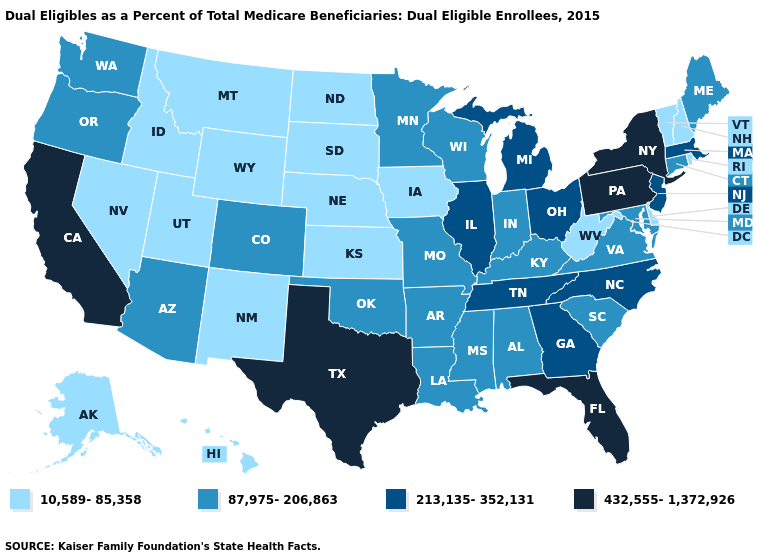Among the states that border Virginia , does West Virginia have the lowest value?
Write a very short answer. Yes. What is the lowest value in the Northeast?
Answer briefly. 10,589-85,358. What is the lowest value in the South?
Be succinct. 10,589-85,358. What is the value of New Jersey?
Write a very short answer. 213,135-352,131. Which states have the lowest value in the MidWest?
Quick response, please. Iowa, Kansas, Nebraska, North Dakota, South Dakota. Among the states that border Nevada , which have the lowest value?
Short answer required. Idaho, Utah. Name the states that have a value in the range 213,135-352,131?
Concise answer only. Georgia, Illinois, Massachusetts, Michigan, New Jersey, North Carolina, Ohio, Tennessee. What is the value of Hawaii?
Short answer required. 10,589-85,358. Does the first symbol in the legend represent the smallest category?
Write a very short answer. Yes. What is the value of Montana?
Be succinct. 10,589-85,358. Name the states that have a value in the range 213,135-352,131?
Short answer required. Georgia, Illinois, Massachusetts, Michigan, New Jersey, North Carolina, Ohio, Tennessee. What is the highest value in the Northeast ?
Answer briefly. 432,555-1,372,926. What is the value of Kentucky?
Short answer required. 87,975-206,863. Does New York have the highest value in the USA?
Quick response, please. Yes. What is the value of Maine?
Concise answer only. 87,975-206,863. 